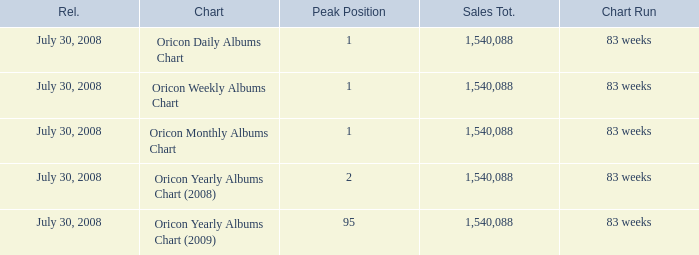Which Sales Total has a Chart of oricon monthly albums chart? 1540088.0. 